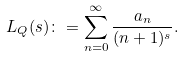Convert formula to latex. <formula><loc_0><loc_0><loc_500><loc_500>L _ { Q } ( s ) \colon = \sum _ { n = 0 } ^ { \infty } \frac { a _ { n } } { ( n + 1 ) ^ { s } } .</formula> 